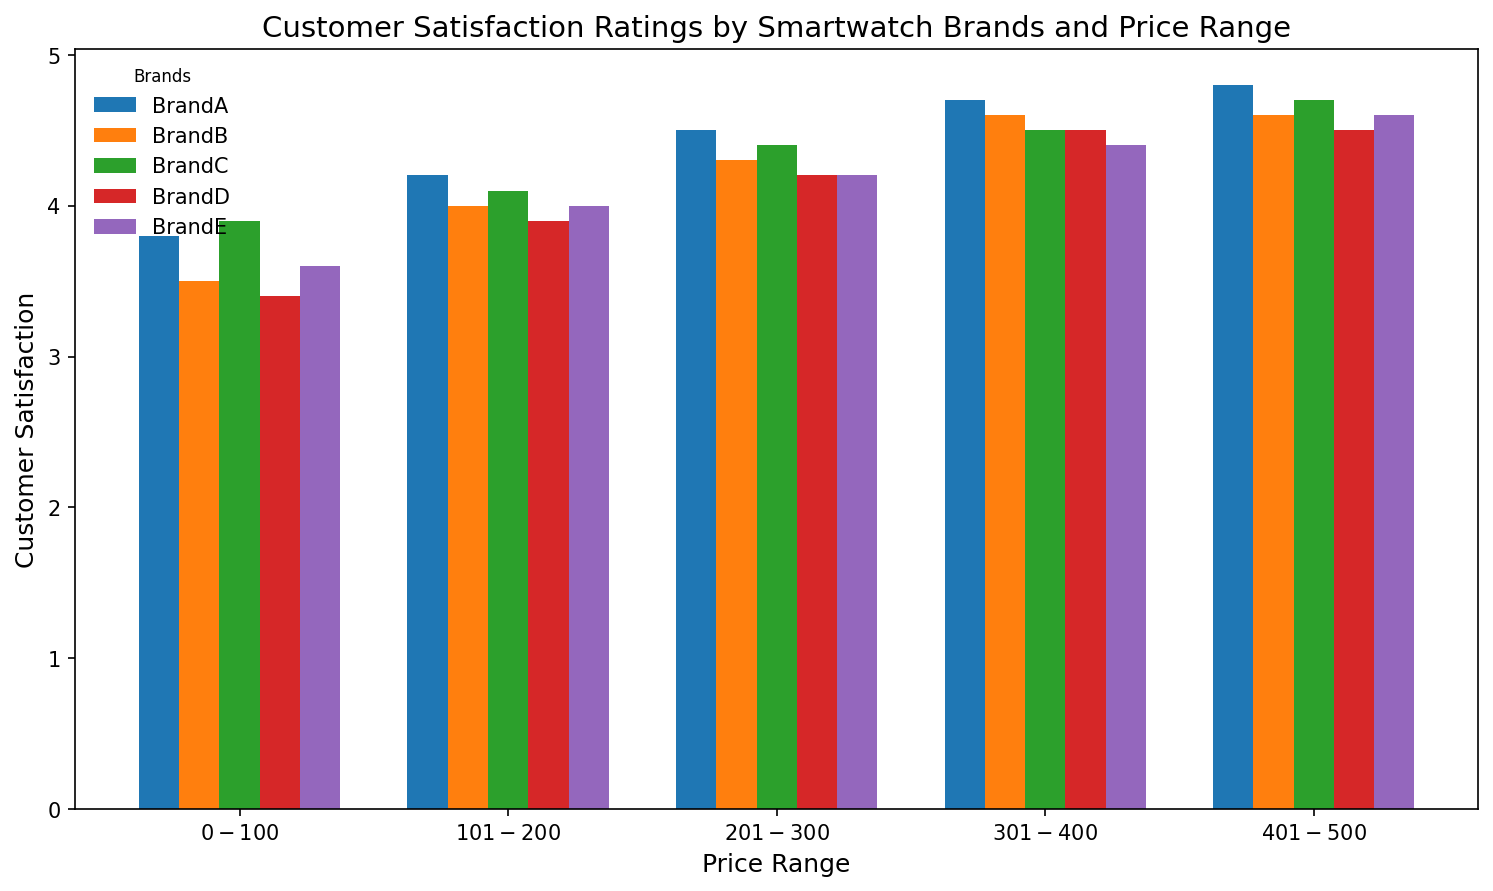Which brand has the highest customer satisfaction in the $401-$500 price range? Look at the bars corresponding to the $401-$500 price range and identify the tallest one. The highest bar in this range belongs to Brand A, with a rating of 4.8.
Answer: Brand A Which price range shows the biggest difference in customer satisfaction between Brand B and Brand C? Compare the differences in bar heights for each price range for Brand B and Brand C. The biggest difference is in the $401-$500 range, where Brand C has a rating of 4.7 and Brand B has 4.6, making a difference of 0.1.
Answer: $401-$500 What is the average customer satisfaction rating for Brand D across all price ranges? Add the customer satisfaction values for each price range for Brand D (3.4 + 3.9 + 4.2 + 4.5 + 4.5) and divide by the number of price ranges (5). The sum is 20.5, and the average is 20.5 / 5 = 4.1.
Answer: 4.1 How does the customer satisfaction of Brand E in the $0-$100 range compare to Brand B in the same range? Compare the heights of the bars for Brand E and Brand B in the $0-$100 range. Brand E has a satisfaction rating of 3.6, while Brand B has a rating of 3.5.
Answer: Brand E is higher Which brand shows the most consistent customer satisfaction ratings across all price ranges? Look for the brand whose bars are closest in height across all price ranges. Brand C shows consistently high ratings relatively close together in height (3.9, 4.1, 4.4, 4.5, 4.7).
Answer: Brand C What is the total customer satisfaction for Brand A across all price ranges? Add up all the customer satisfaction ratings for Brand A (3.8 + 4.2 + 4.5 + 4.7 + 4.8). The total is 22.0.
Answer: 22.0 Which price range has the largest overall customer satisfaction rating difference between the highest and lowest ratings? For each price range, identify the highest and lowest ratings and calculate their differences. The $401-$500 range has the largest difference with Brand A at 4.8 and Brand D at 4.5, making a difference of 0.3.
Answer: $401-$500 In which price range does Brand A experience the most significant increase in customer satisfaction compared to the previous price range? Compare the difference in customer satisfaction for Brand A between consecutive price ranges. From $301-$400 to $401-$500, the rating increases from 4.7 to 4.8, a difference of 0.1. However, a more significant increase is from $101-$200 to $201-$300, with an increase from 4.2 to 4.5, which is 0.3.
Answer: $201-$300 What is the visual difference in height between the bars for Brand B and Brand D in the $201-$300 range? The ratings for Brand B and Brand D in the $201-$300 range are 4.3 and 4.2, respectively. This means Brand B's bar is slightly higher by a margin of 0.1.
Answer: Brand B is slightly higher 